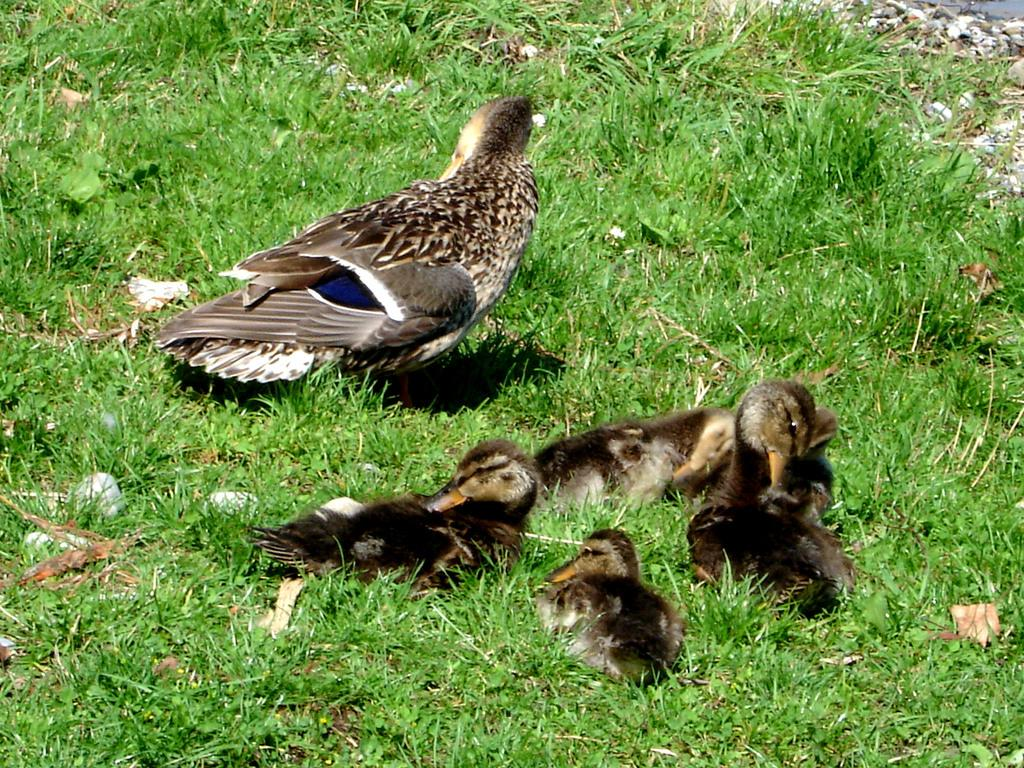What type of surface is visible in the image? There is ground visible in the image. What type of vegetation is present on the ground? There is grass on the ground. What type of animals can be seen in the image? There are birds in the image. What colors can be observed on the birds? The birds have brown, cream, blue, and black colors. What type of face can be seen on the grass in the image? There is no face present on the grass in the image. Can you copy the image onto a piece of paper? The question is not about the image itself, but rather about creating a physical copy of it. However, the image cannot be copied directly from the text. 